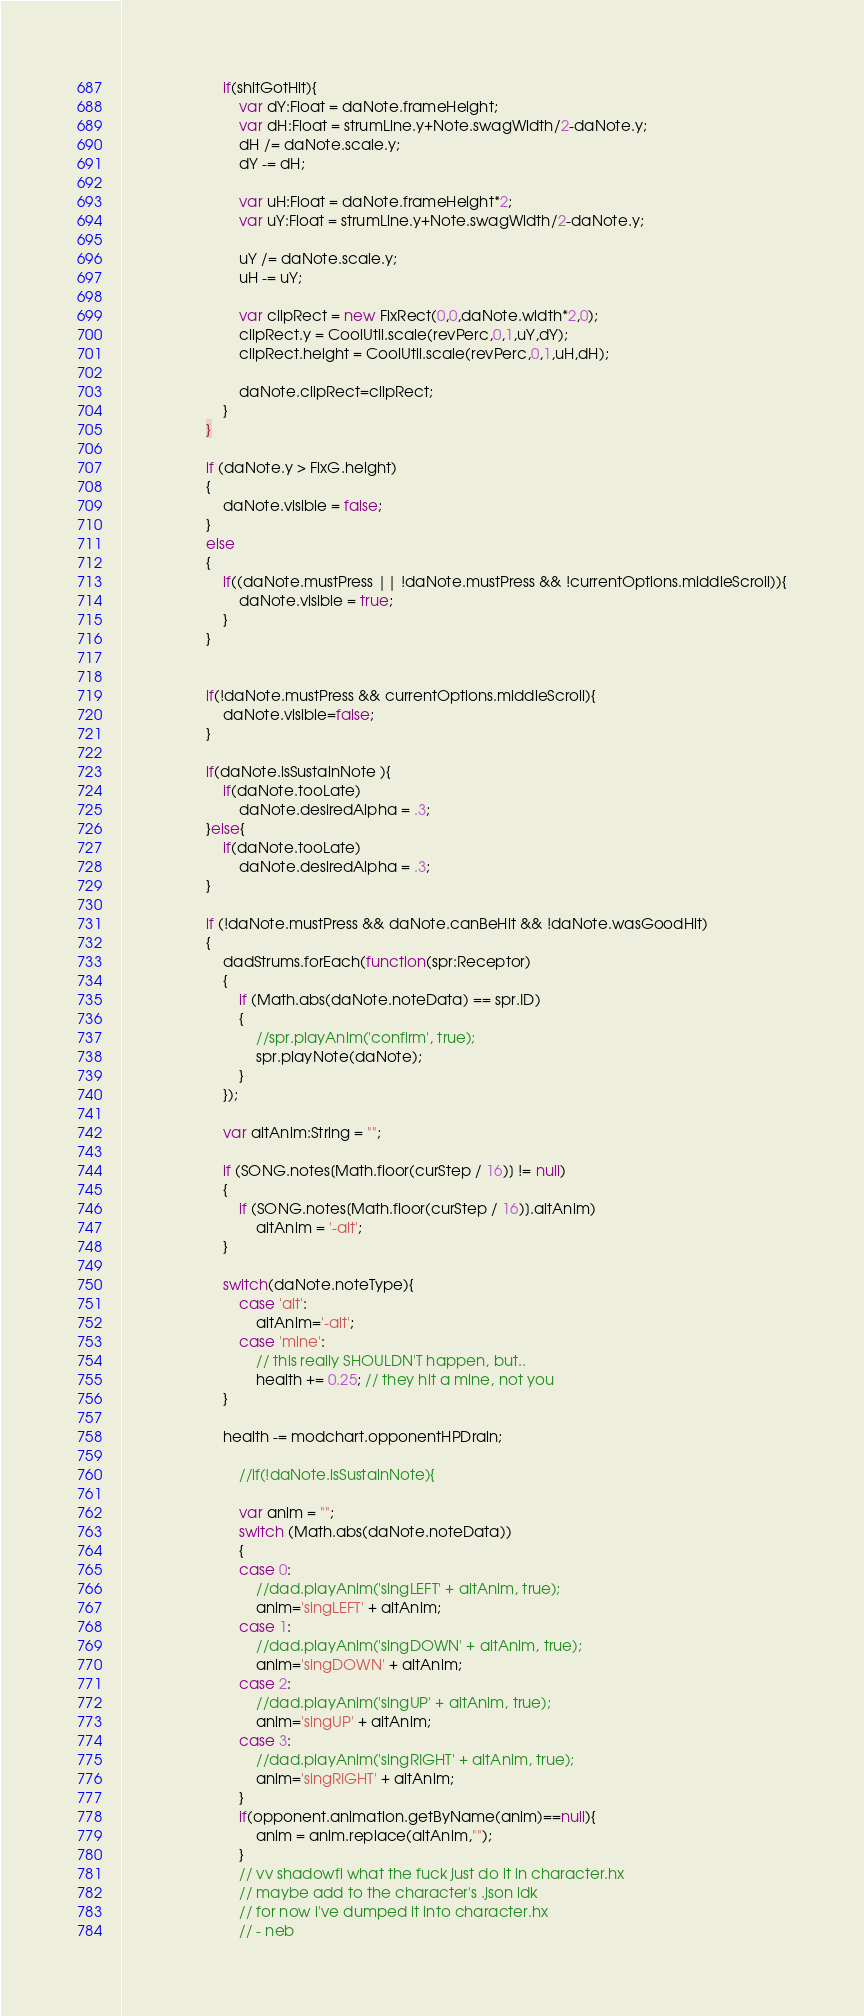Convert code to text. <code><loc_0><loc_0><loc_500><loc_500><_Haxe_>						if(shitGotHit){
							var dY:Float = daNote.frameHeight;
							var dH:Float = strumLine.y+Note.swagWidth/2-daNote.y;
							dH /= daNote.scale.y;
							dY -= dH;

							var uH:Float = daNote.frameHeight*2;
							var uY:Float = strumLine.y+Note.swagWidth/2-daNote.y;

							uY /= daNote.scale.y;
							uH -= uY;

							var clipRect = new FlxRect(0,0,daNote.width*2,0);
							clipRect.y = CoolUtil.scale(revPerc,0,1,uY,dY);
							clipRect.height = CoolUtil.scale(revPerc,0,1,uH,dH);

							daNote.clipRect=clipRect;
						}
					}

					if (daNote.y > FlxG.height)
					{
						daNote.visible = false;
					}
					else
					{
						if((daNote.mustPress || !daNote.mustPress && !currentOptions.middleScroll)){
							daNote.visible = true;
						}
					}


					if(!daNote.mustPress && currentOptions.middleScroll){
						daNote.visible=false;
					}

					if(daNote.isSustainNote ){
						if(daNote.tooLate)
							daNote.desiredAlpha = .3;
					}else{
						if(daNote.tooLate)
							daNote.desiredAlpha = .3;
					}

					if (!daNote.mustPress && daNote.canBeHit && !daNote.wasGoodHit)
					{
						dadStrums.forEach(function(spr:Receptor)
						{
							if (Math.abs(daNote.noteData) == spr.ID)
							{
								//spr.playAnim('confirm', true);
								spr.playNote(daNote);
							}
						});

						var altAnim:String = "";

						if (SONG.notes[Math.floor(curStep / 16)] != null)
						{
							if (SONG.notes[Math.floor(curStep / 16)].altAnim)
								altAnim = '-alt';
						}

						switch(daNote.noteType){
							case 'alt':
								altAnim='-alt';
							case 'mine':
								// this really SHOULDN'T happen, but..
								health += 0.25; // they hit a mine, not you
						}

						health -= modchart.opponentHPDrain;

							//if(!daNote.isSustainNote){

							var anim = "";
							switch (Math.abs(daNote.noteData))
							{
							case 0:
								//dad.playAnim('singLEFT' + altAnim, true);
								anim='singLEFT' + altAnim;
							case 1:
								//dad.playAnim('singDOWN' + altAnim, true);
								anim='singDOWN' + altAnim;
							case 2:
								//dad.playAnim('singUP' + altAnim, true);
								anim='singUP' + altAnim;
							case 3:
								//dad.playAnim('singRIGHT' + altAnim, true);
								anim='singRIGHT' + altAnim;
							}
							if(opponent.animation.getByName(anim)==null){
								anim = anim.replace(altAnim,"");
							}
							// vv shadowfi what the fuck just do it in character.hx
							// maybe add to the character's .json idk
							// for now i've dumped it into character.hx
							// - neb
</code> 